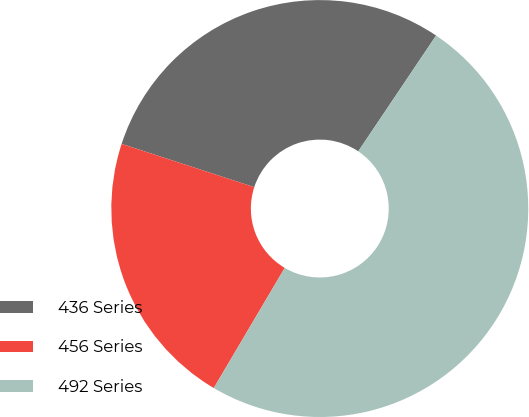Convert chart. <chart><loc_0><loc_0><loc_500><loc_500><pie_chart><fcel>436 Series<fcel>456 Series<fcel>492 Series<nl><fcel>29.4%<fcel>21.53%<fcel>49.07%<nl></chart> 